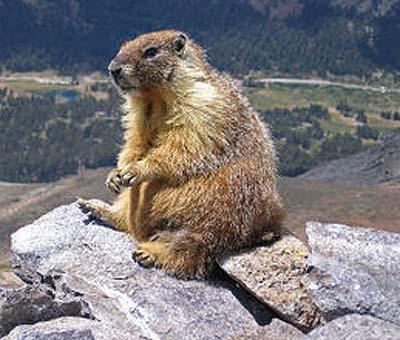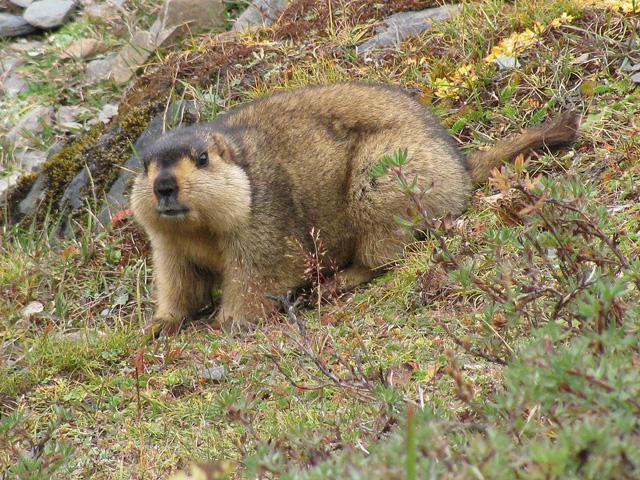The first image is the image on the left, the second image is the image on the right. Analyze the images presented: Is the assertion "There is at least one animal lying on its belly and facing left in the image on the left." valid? Answer yes or no. No. 